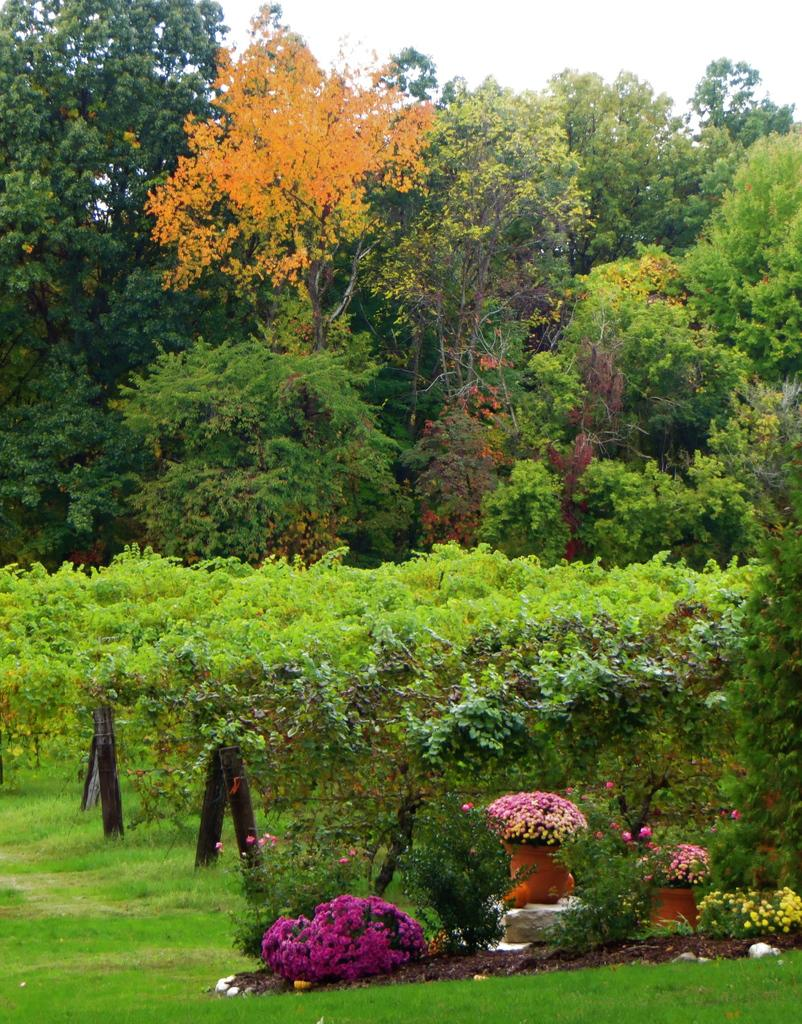What type of vegetation can be seen in the image? There are plants, flowers, grass, and trees in the image. What are the plants contained in? There are pots in the image that contain the plants. What can be seen in the background of the image? The sky is visible in the background of the image. Can you read the verse written on the goldfish in the image? There is no goldfish present in the image, and therefore no verse can be read from it. 